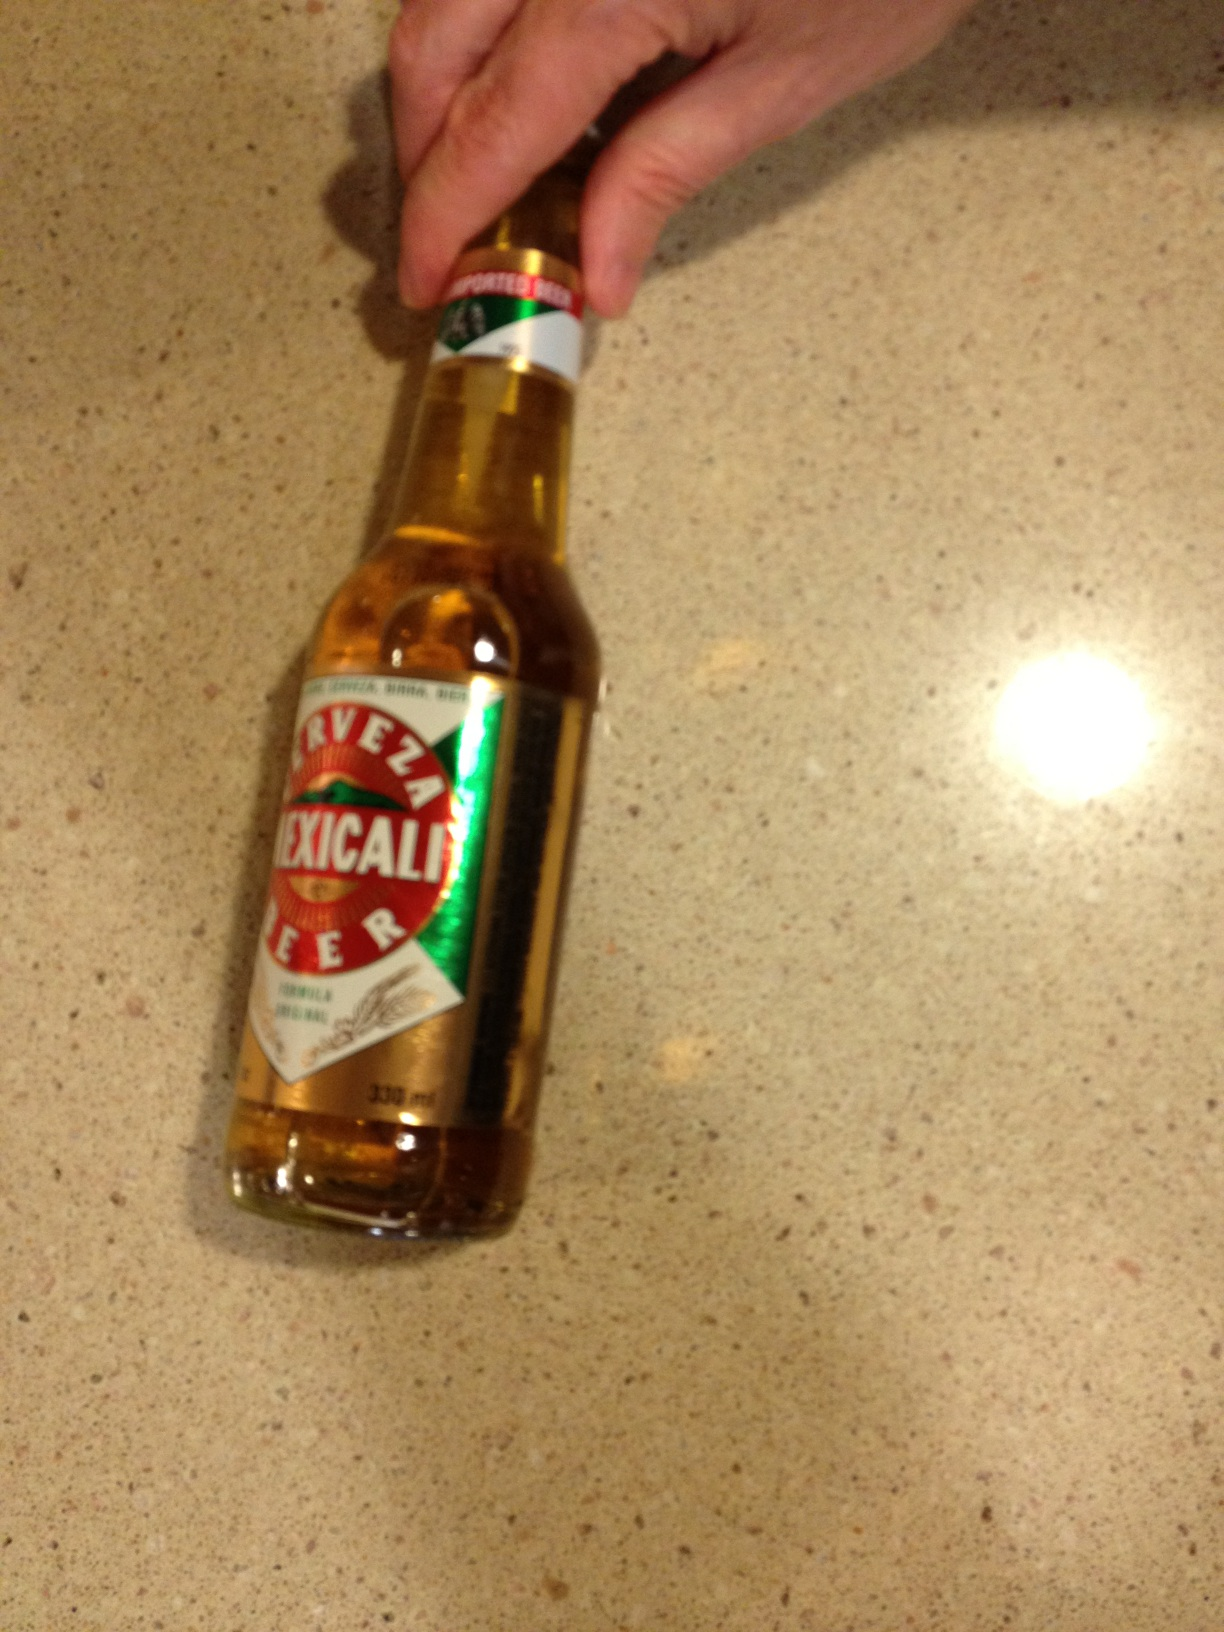I know I can't record very well but could you tell me if you can figure it out what kind of beer this is? Thank you, from Vizwiz cerveza mexicali beer 